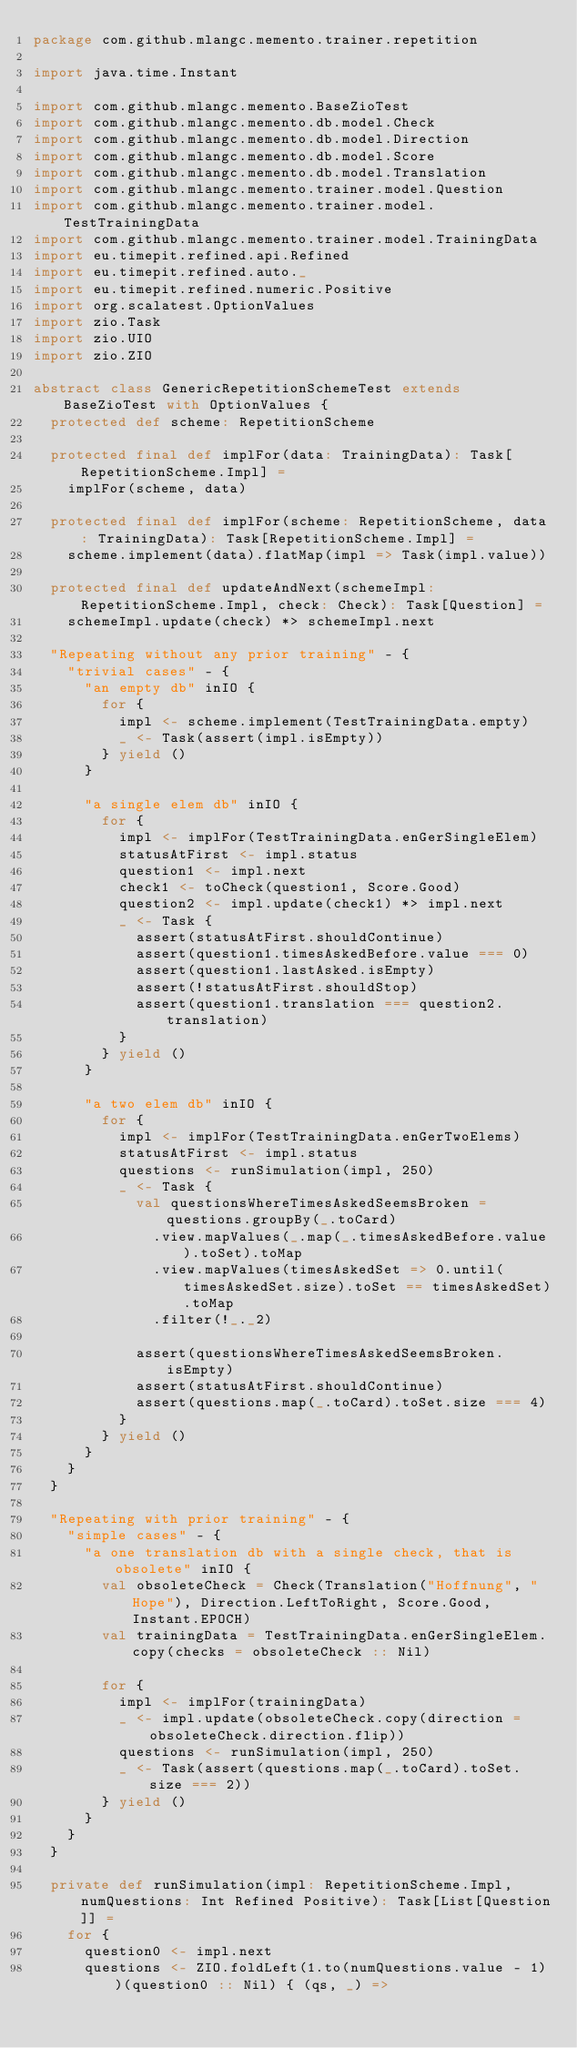<code> <loc_0><loc_0><loc_500><loc_500><_Scala_>package com.github.mlangc.memento.trainer.repetition

import java.time.Instant

import com.github.mlangc.memento.BaseZioTest
import com.github.mlangc.memento.db.model.Check
import com.github.mlangc.memento.db.model.Direction
import com.github.mlangc.memento.db.model.Score
import com.github.mlangc.memento.db.model.Translation
import com.github.mlangc.memento.trainer.model.Question
import com.github.mlangc.memento.trainer.model.TestTrainingData
import com.github.mlangc.memento.trainer.model.TrainingData
import eu.timepit.refined.api.Refined
import eu.timepit.refined.auto._
import eu.timepit.refined.numeric.Positive
import org.scalatest.OptionValues
import zio.Task
import zio.UIO
import zio.ZIO

abstract class GenericRepetitionSchemeTest extends BaseZioTest with OptionValues {
  protected def scheme: RepetitionScheme

  protected final def implFor(data: TrainingData): Task[RepetitionScheme.Impl] =
    implFor(scheme, data)

  protected final def implFor(scheme: RepetitionScheme, data: TrainingData): Task[RepetitionScheme.Impl] =
    scheme.implement(data).flatMap(impl => Task(impl.value))

  protected final def updateAndNext(schemeImpl: RepetitionScheme.Impl, check: Check): Task[Question] =
    schemeImpl.update(check) *> schemeImpl.next

  "Repeating without any prior training" - {
    "trivial cases" - {
      "an empty db" inIO {
        for {
          impl <- scheme.implement(TestTrainingData.empty)
          _ <- Task(assert(impl.isEmpty))
        } yield ()
      }

      "a single elem db" inIO {
        for {
          impl <- implFor(TestTrainingData.enGerSingleElem)
          statusAtFirst <- impl.status
          question1 <- impl.next
          check1 <- toCheck(question1, Score.Good)
          question2 <- impl.update(check1) *> impl.next
          _ <- Task {
            assert(statusAtFirst.shouldContinue)
            assert(question1.timesAskedBefore.value === 0)
            assert(question1.lastAsked.isEmpty)
            assert(!statusAtFirst.shouldStop)
            assert(question1.translation === question2.translation)
          }
        } yield ()
      }

      "a two elem db" inIO {
        for {
          impl <- implFor(TestTrainingData.enGerTwoElems)
          statusAtFirst <- impl.status
          questions <- runSimulation(impl, 250)
          _ <- Task {
            val questionsWhereTimesAskedSeemsBroken = questions.groupBy(_.toCard)
              .view.mapValues(_.map(_.timesAskedBefore.value).toSet).toMap
              .view.mapValues(timesAskedSet => 0.until(timesAskedSet.size).toSet == timesAskedSet).toMap
              .filter(!_._2)

            assert(questionsWhereTimesAskedSeemsBroken.isEmpty)
            assert(statusAtFirst.shouldContinue)
            assert(questions.map(_.toCard).toSet.size === 4)
          }
        } yield ()
      }
    }
  }

  "Repeating with prior training" - {
    "simple cases" - {
      "a one translation db with a single check, that is obsolete" inIO {
        val obsoleteCheck = Check(Translation("Hoffnung", "Hope"), Direction.LeftToRight, Score.Good, Instant.EPOCH)
        val trainingData = TestTrainingData.enGerSingleElem.copy(checks = obsoleteCheck :: Nil)

        for {
          impl <- implFor(trainingData)
          _ <- impl.update(obsoleteCheck.copy(direction = obsoleteCheck.direction.flip))
          questions <- runSimulation(impl, 250)
          _ <- Task(assert(questions.map(_.toCard).toSet.size === 2))
        } yield ()
      }
    }
  }

  private def runSimulation(impl: RepetitionScheme.Impl, numQuestions: Int Refined Positive): Task[List[Question]] =
    for {
      question0 <- impl.next
      questions <- ZIO.foldLeft(1.to(numQuestions.value - 1))(question0 :: Nil) { (qs, _) =></code> 